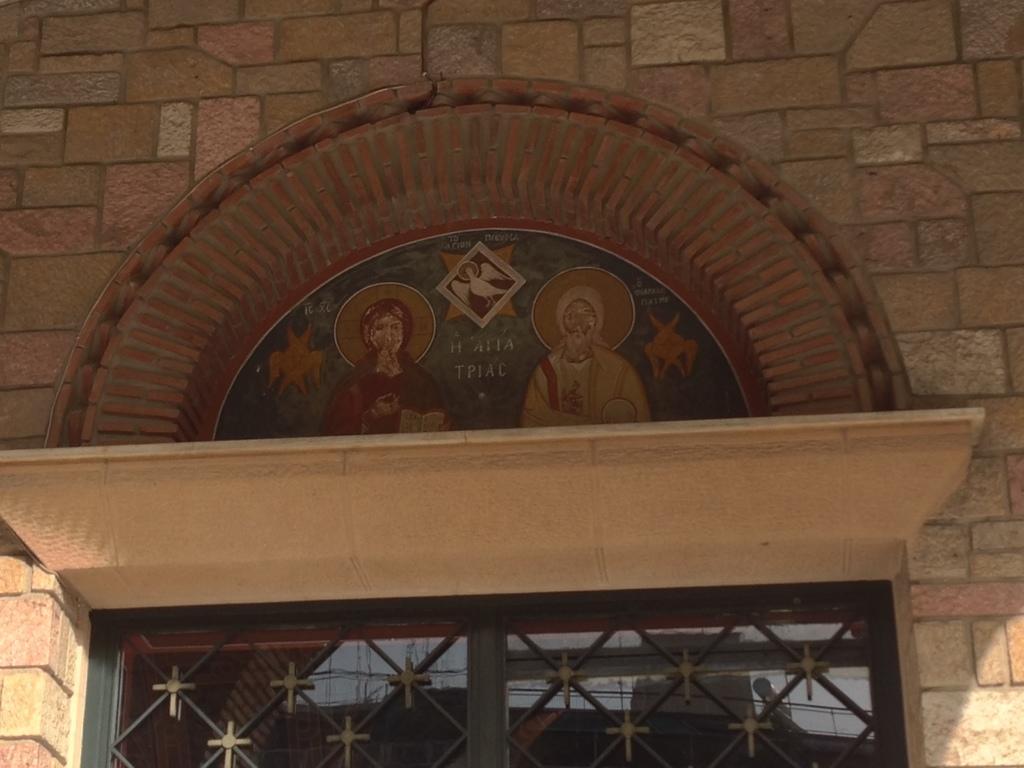Please provide a concise description of this image. In this image there is a building with a wall and a window. There are a few carvings on the wall and there is a board with a text and a few images on it. 